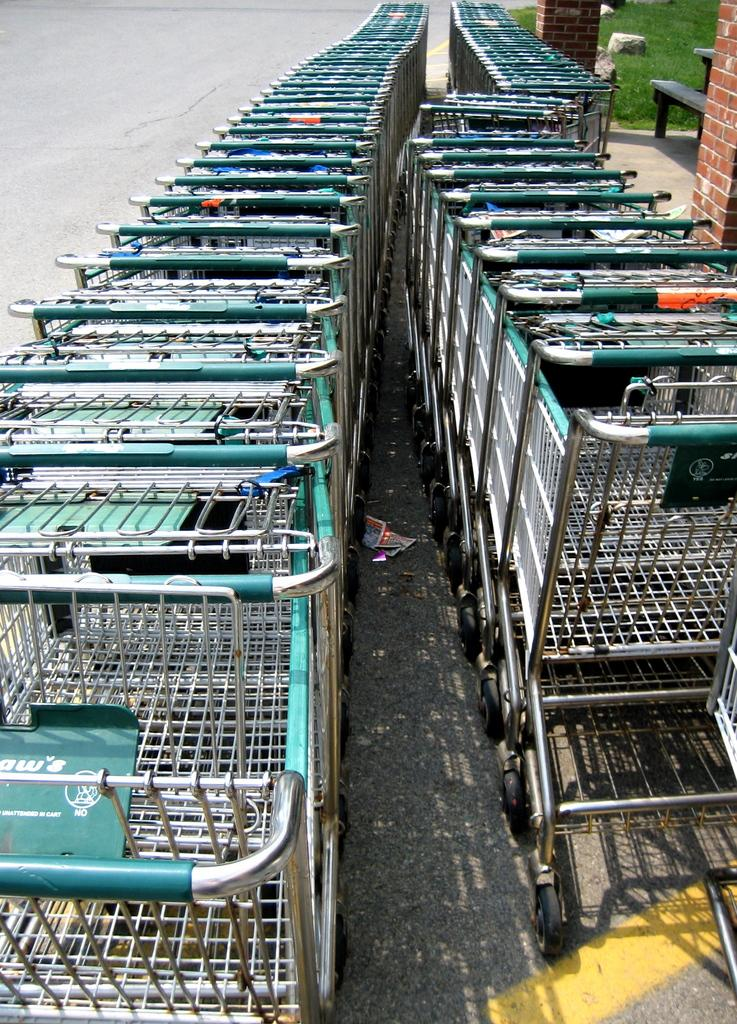<image>
Present a compact description of the photo's key features. Shopping carts in a row with the word "NO" on it. 